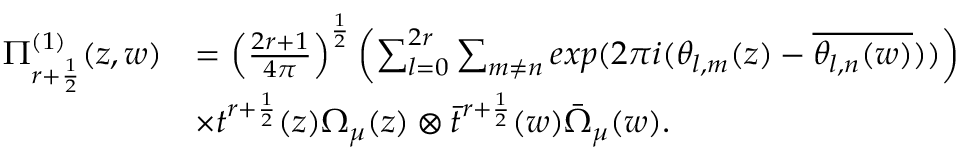Convert formula to latex. <formula><loc_0><loc_0><loc_500><loc_500>\begin{array} { r l } { \Pi _ { r + \frac { 1 } { 2 } } ^ { ( 1 ) } ( z , w ) } & { = \left ( \frac { 2 r + 1 } { 4 \pi } \right ) ^ { \frac { 1 } { 2 } } \left ( \sum _ { l = 0 } ^ { 2 r } \sum _ { m \neq n } e x p ( 2 \pi i ( \theta _ { l , m } ( z ) - \overline { { \theta _ { l , n } ( w ) } } ) ) \right ) } \\ & { \times t ^ { r + \frac { 1 } { 2 } } ( z ) \Omega _ { \mu } ( z ) \otimes \bar { t } ^ { r + \frac { 1 } { 2 } } ( w ) \bar { \Omega } _ { \mu } ( w ) . } \end{array}</formula> 